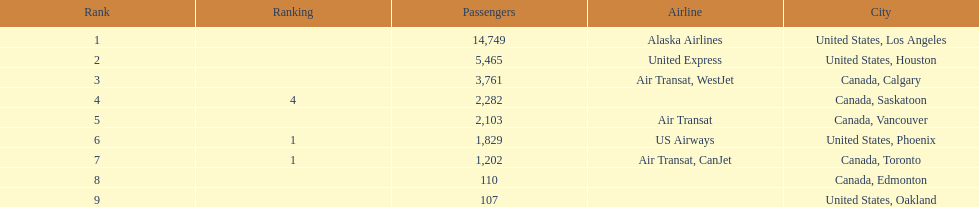Los angeles and what other city had about 19,000 passenger combined Canada, Calgary. 